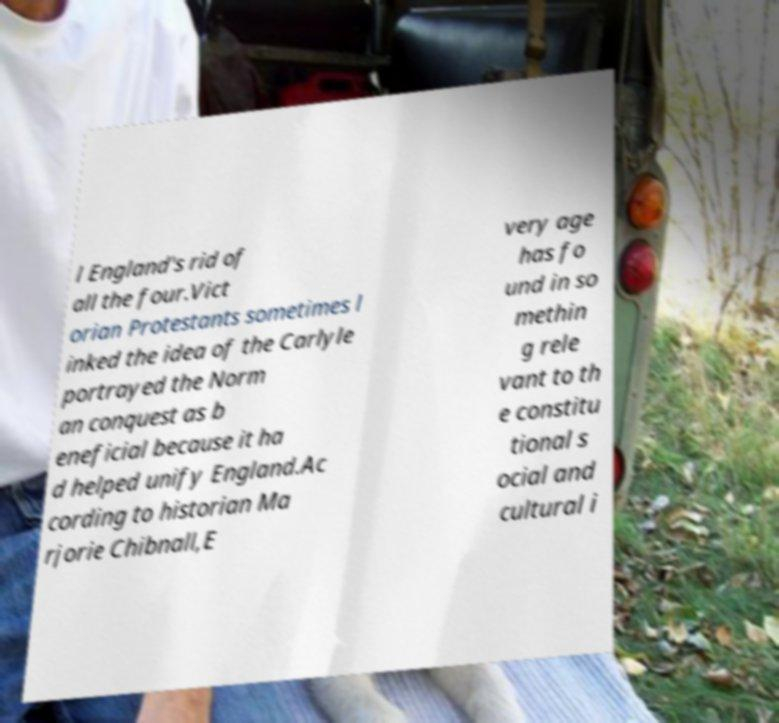I need the written content from this picture converted into text. Can you do that? l England's rid of all the four.Vict orian Protestants sometimes l inked the idea of the Carlyle portrayed the Norm an conquest as b eneficial because it ha d helped unify England.Ac cording to historian Ma rjorie Chibnall,E very age has fo und in so methin g rele vant to th e constitu tional s ocial and cultural i 